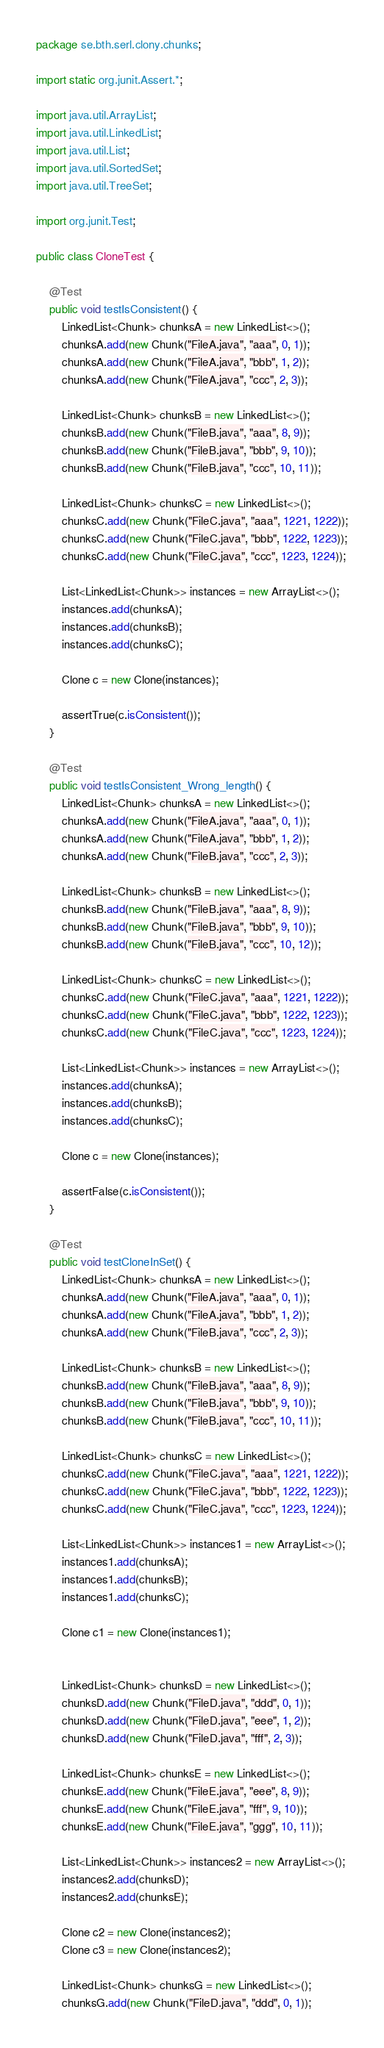<code> <loc_0><loc_0><loc_500><loc_500><_Java_>package se.bth.serl.clony.chunks;

import static org.junit.Assert.*;

import java.util.ArrayList;
import java.util.LinkedList;
import java.util.List;
import java.util.SortedSet;
import java.util.TreeSet;

import org.junit.Test;

public class CloneTest {

	@Test
	public void testIsConsistent() {
		LinkedList<Chunk> chunksA = new LinkedList<>();
		chunksA.add(new Chunk("FileA.java", "aaa", 0, 1));
		chunksA.add(new Chunk("FileA.java", "bbb", 1, 2));
		chunksA.add(new Chunk("FileA.java", "ccc", 2, 3));

		LinkedList<Chunk> chunksB = new LinkedList<>();
		chunksB.add(new Chunk("FileB.java", "aaa", 8, 9));
		chunksB.add(new Chunk("FileB.java", "bbb", 9, 10));
		chunksB.add(new Chunk("FileB.java", "ccc", 10, 11));

		LinkedList<Chunk> chunksC = new LinkedList<>();
		chunksC.add(new Chunk("FileC.java", "aaa", 1221, 1222));
		chunksC.add(new Chunk("FileC.java", "bbb", 1222, 1223));
		chunksC.add(new Chunk("FileC.java", "ccc", 1223, 1224));

		List<LinkedList<Chunk>> instances = new ArrayList<>();
		instances.add(chunksA);
		instances.add(chunksB);
		instances.add(chunksC);

		Clone c = new Clone(instances);

		assertTrue(c.isConsistent());
	}
	
	@Test
	public void testIsConsistent_Wrong_length() {
		LinkedList<Chunk> chunksA = new LinkedList<>();
		chunksA.add(new Chunk("FileA.java", "aaa", 0, 1));
		chunksA.add(new Chunk("FileA.java", "bbb", 1, 2));
		chunksA.add(new Chunk("FileB.java", "ccc", 2, 3));
		
		LinkedList<Chunk> chunksB = new LinkedList<>();
		chunksB.add(new Chunk("FileB.java", "aaa", 8, 9));
		chunksB.add(new Chunk("FileB.java", "bbb", 9, 10));
		chunksB.add(new Chunk("FileB.java", "ccc", 10, 12));
		
		LinkedList<Chunk> chunksC = new LinkedList<>();
		chunksC.add(new Chunk("FileC.java", "aaa", 1221, 1222));
		chunksC.add(new Chunk("FileC.java", "bbb", 1222, 1223));
		chunksC.add(new Chunk("FileC.java", "ccc", 1223, 1224));
		
		List<LinkedList<Chunk>> instances = new ArrayList<>();
		instances.add(chunksA);
		instances.add(chunksB);
		instances.add(chunksC);
		
		Clone c = new Clone(instances);
		
		assertFalse(c.isConsistent());
	}
	
	@Test
	public void testCloneInSet() {
		LinkedList<Chunk> chunksA = new LinkedList<>();
		chunksA.add(new Chunk("FileA.java", "aaa", 0, 1));
		chunksA.add(new Chunk("FileA.java", "bbb", 1, 2));
		chunksA.add(new Chunk("FileB.java", "ccc", 2, 3));

		LinkedList<Chunk> chunksB = new LinkedList<>();
		chunksB.add(new Chunk("FileB.java", "aaa", 8, 9));
		chunksB.add(new Chunk("FileB.java", "bbb", 9, 10));
		chunksB.add(new Chunk("FileB.java", "ccc", 10, 11));
		
		LinkedList<Chunk> chunksC = new LinkedList<>();
		chunksC.add(new Chunk("FileC.java", "aaa", 1221, 1222));
		chunksC.add(new Chunk("FileC.java", "bbb", 1222, 1223));
		chunksC.add(new Chunk("FileC.java", "ccc", 1223, 1224));
		
		List<LinkedList<Chunk>> instances1 = new ArrayList<>();
		instances1.add(chunksA);
		instances1.add(chunksB);
		instances1.add(chunksC);
		
		Clone c1 = new Clone(instances1);
	
		
		LinkedList<Chunk> chunksD = new LinkedList<>();
		chunksD.add(new Chunk("FileD.java", "ddd", 0, 1));
		chunksD.add(new Chunk("FileD.java", "eee", 1, 2));
		chunksD.add(new Chunk("FileD.java", "fff", 2, 3));
		
		LinkedList<Chunk> chunksE = new LinkedList<>();
		chunksE.add(new Chunk("FileE.java", "eee", 8, 9));
		chunksE.add(new Chunk("FileE.java", "fff", 9, 10));
		chunksE.add(new Chunk("FileE.java", "ggg", 10, 11));
		
		List<LinkedList<Chunk>> instances2 = new ArrayList<>();
		instances2.add(chunksD);
		instances2.add(chunksE);
		
		Clone c2 = new Clone(instances2);
		Clone c3 = new Clone(instances2);
		
		LinkedList<Chunk> chunksG = new LinkedList<>();
		chunksG.add(new Chunk("FileD.java", "ddd", 0, 1));</code> 